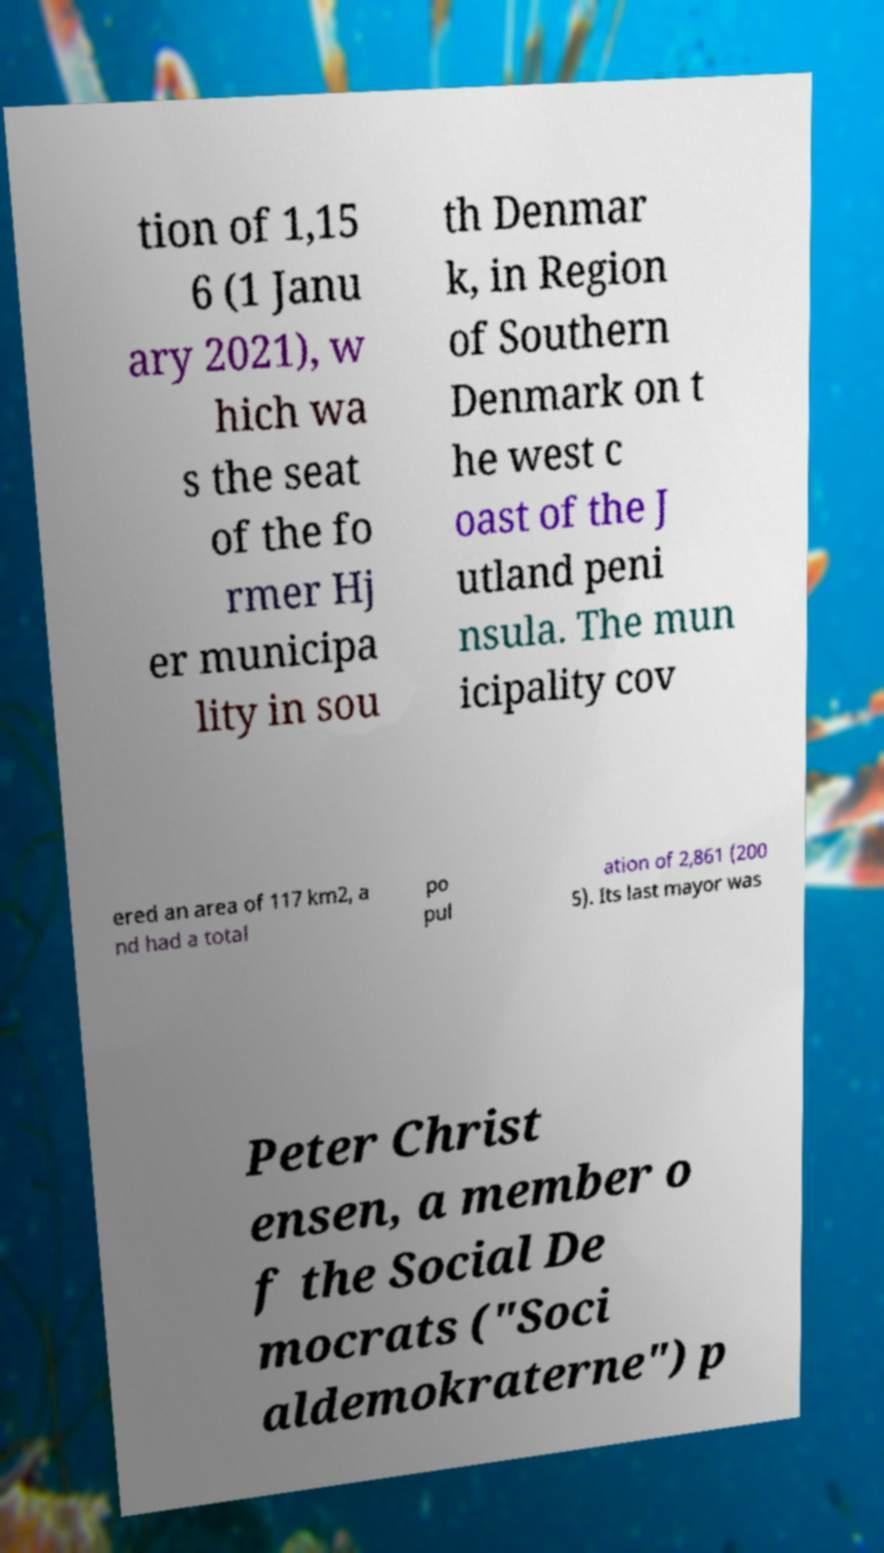For documentation purposes, I need the text within this image transcribed. Could you provide that? tion of 1,15 6 (1 Janu ary 2021), w hich wa s the seat of the fo rmer Hj er municipa lity in sou th Denmar k, in Region of Southern Denmark on t he west c oast of the J utland peni nsula. The mun icipality cov ered an area of 117 km2, a nd had a total po pul ation of 2,861 (200 5). Its last mayor was Peter Christ ensen, a member o f the Social De mocrats ("Soci aldemokraterne") p 